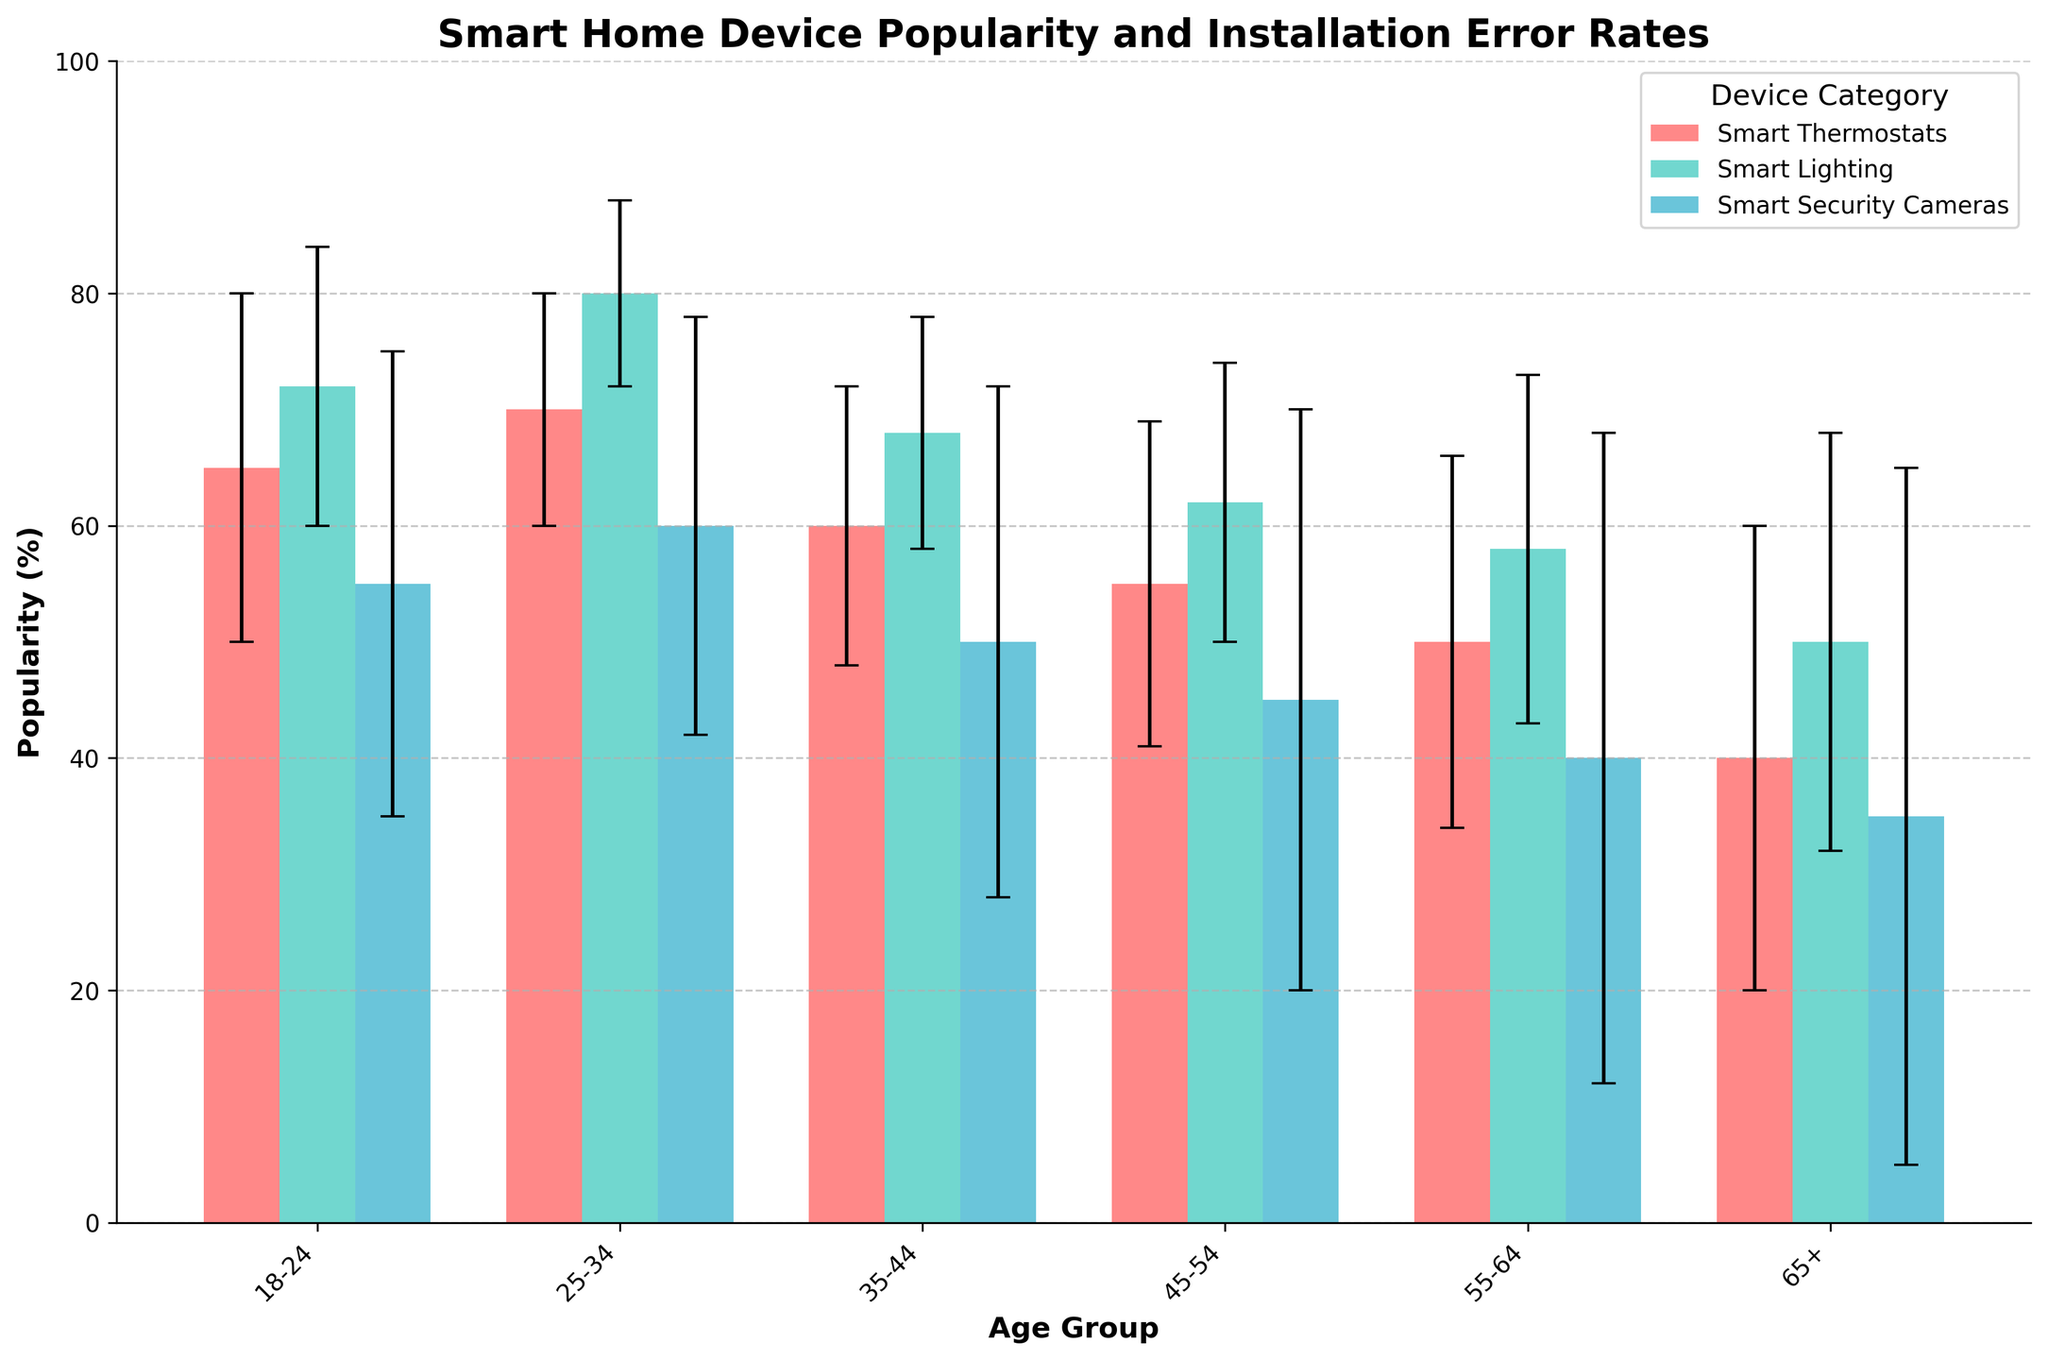What is the title of the figure? The title is generally placed at the top of the figure, often in bold to make it prominent. Here, the title "Smart Home Device Popularity and Installation Error Rates" is presented at the top in bold.
Answer: Smart Home Device Popularity and Installation Error Rates Which age group has the highest popularity for Smart Lighting? To answer this, look for the highest bar in the Smart Lighting category. The age group 25-34 has the highest popularity for Smart Lighting at 80%.
Answer: 25-34 What is the installation error rate for Smart Security Cameras in the 65+ age group? Installation error rates are marked by the error bars on top of the bars. For the 65+ age group and Smart Security Cameras, the error bar extends to 30%.
Answer: 30% For the age group 45-54, what is the difference in popularity between Smart Thermostats and Smart Security Cameras? Look at the bars for Smart Thermostats and Smart Security Cameras in the 45-54 age group. The popularity of Smart Thermostats is 55%, and for Smart Security Cameras, it is 45%. Subtract the smaller value from the larger one: 55% - 45% = 10%.
Answer: 10% Which device category shows the largest variation in popularity across the age groups? Identify the device category with the widest range between its highest and lowest values. Smart Lighting ranges from 50% (65+) to 80% (25-34), making it the device with the largest variation in popularity.
Answer: Smart Lighting Comparing the age group 35-44, which device has the lowest popularity rate? Check the heights of the bars for each device category in the 35-44 age group. Smart Security Cameras have the lowest popularity at 50%.
Answer: Smart Security Cameras What is the average popularity of Smart Thermostats across all age groups? Sum the popularity percentages for Smart Thermostats in all age groups and divide by the number of age groups (65 + 70 + 60 + 55 + 50 + 40) / 6. Calculate as follows: (65 + 70 + 60 + 55 + 50 + 40) / 6 = 340/6 = 56.67%.
Answer: 56.67% How does the popularity of Smart Security Cameras change from the 18-24 age group to the 65+ age group? Note the popularity percentages for Smart Security Cameras in the 18-24 age group (55%) and compare it with the 65+ age group (35%). The popularity decreases from 55% to 35%.
Answer: Decreases by 20% In which age group do installation error rates for Smart Lighting stay relatively low? Look at the heights of the error bars for Smart Lighting in each age group. The error rate for Smart Lighting in the 25-34 age group is 8%, which is relatively low compared to other groups.
Answer: 25-34 For the age group 55-64, calculate the sum of installation error rates for all devices. Add the installation error rates for Smart Thermostats (16%), Smart Lighting (15%), and Smart Security Cameras (28%) in the 55-64 age group. Calculate as follows: 16% + 15% + 28% = 59%.
Answer: 59% 